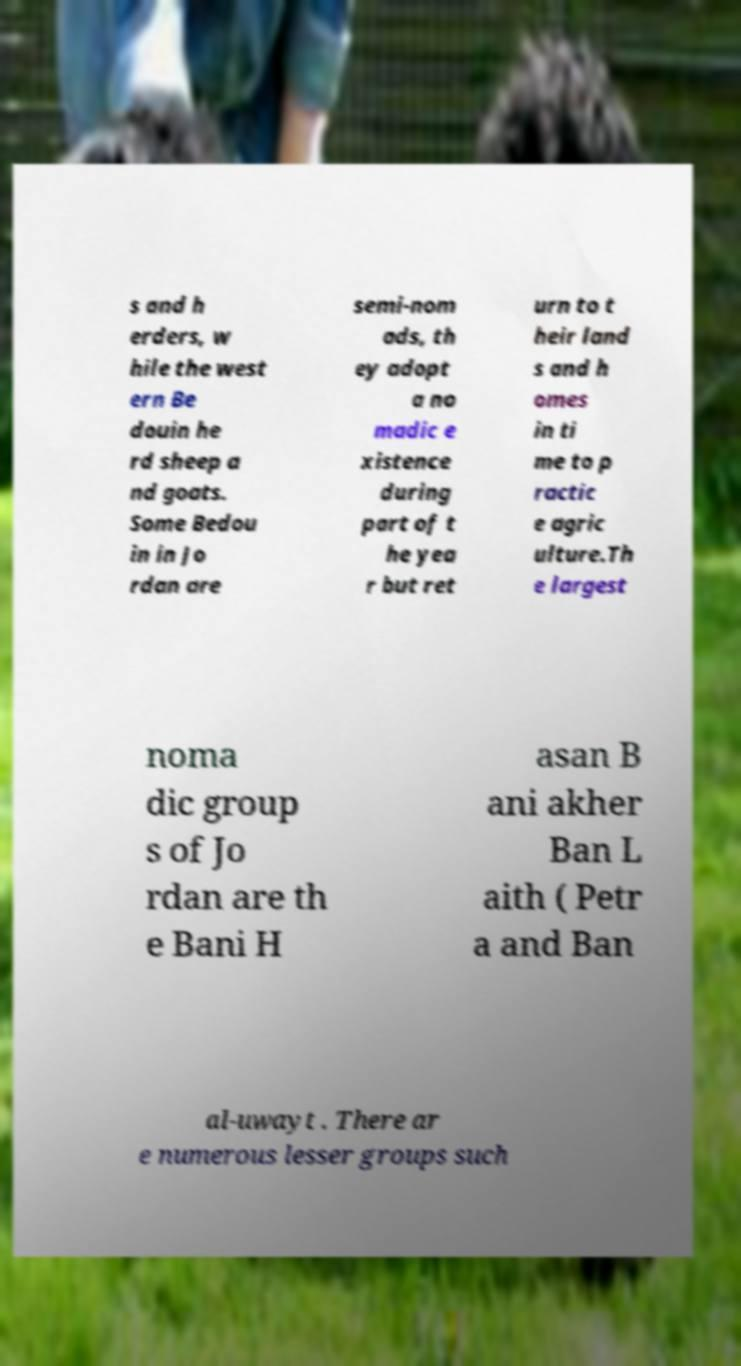Could you assist in decoding the text presented in this image and type it out clearly? s and h erders, w hile the west ern Be douin he rd sheep a nd goats. Some Bedou in in Jo rdan are semi-nom ads, th ey adopt a no madic e xistence during part of t he yea r but ret urn to t heir land s and h omes in ti me to p ractic e agric ulture.Th e largest noma dic group s of Jo rdan are th e Bani H asan B ani akher Ban L aith ( Petr a and Ban al-uwayt . There ar e numerous lesser groups such 